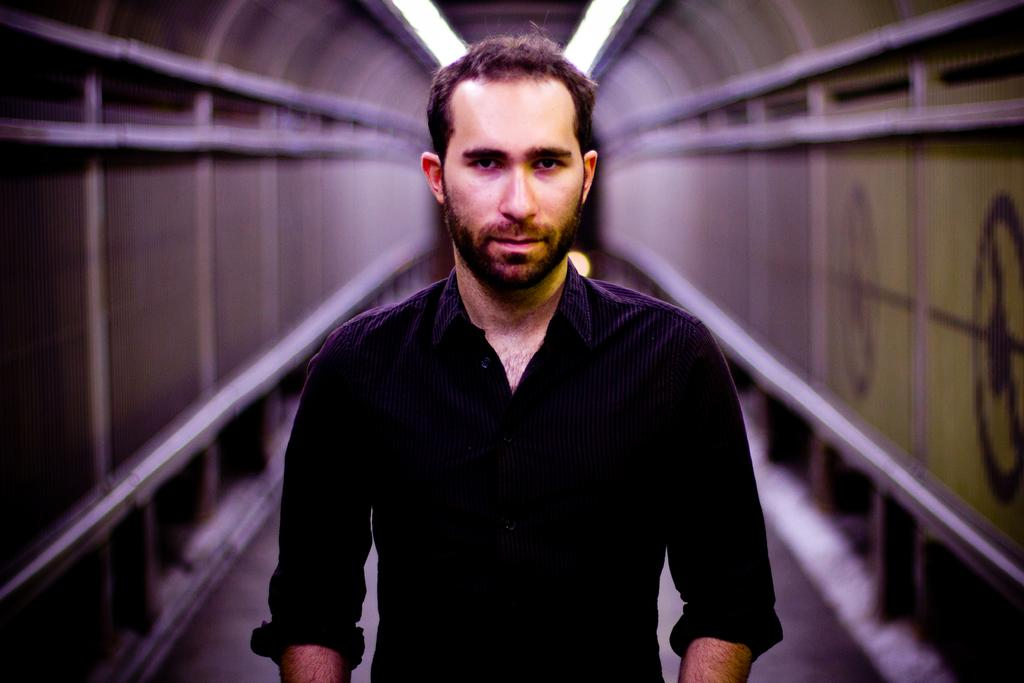Who is present in the image? There is a man in the image. What is the man wearing? The man is wearing a black shirt. What is the man doing in the image? The man is standing in the front and giving a pose. What can be seen in the background of the image? There is an iron tunnel in the background of the image. What type of trees can be seen in the image? There are no trees present in the image; it features a man in front of an iron tunnel. What authority figure is depicted in the image? There is no authority figure depicted in the image; it features a man in a black shirt posing in front of an iron tunnel. 